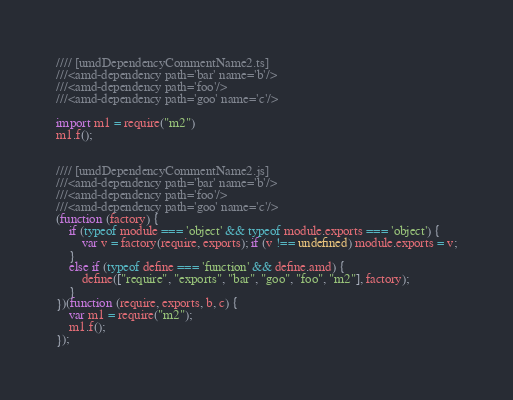Convert code to text. <code><loc_0><loc_0><loc_500><loc_500><_JavaScript_>//// [umdDependencyCommentName2.ts]
///<amd-dependency path='bar' name='b'/>
///<amd-dependency path='foo'/>
///<amd-dependency path='goo' name='c'/>

import m1 = require("m2")
m1.f();


//// [umdDependencyCommentName2.js]
///<amd-dependency path='bar' name='b'/>
///<amd-dependency path='foo'/>
///<amd-dependency path='goo' name='c'/>
(function (factory) {
    if (typeof module === 'object' && typeof module.exports === 'object') {
        var v = factory(require, exports); if (v !== undefined) module.exports = v;
    }
    else if (typeof define === 'function' && define.amd) {
        define(["require", "exports", "bar", "goo", "foo", "m2"], factory);
    }
})(function (require, exports, b, c) {
    var m1 = require("m2");
    m1.f();
});
</code> 